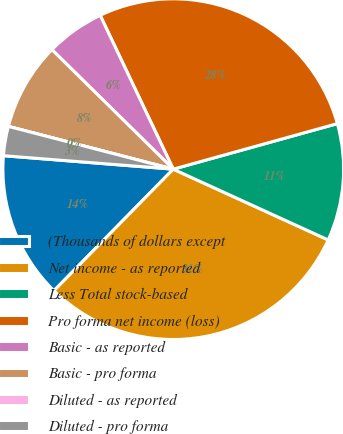Convert chart. <chart><loc_0><loc_0><loc_500><loc_500><pie_chart><fcel>(Thousands of dollars except<fcel>Net income - as reported<fcel>Less Total stock-based<fcel>Pro forma net income (loss)<fcel>Basic - as reported<fcel>Basic - pro forma<fcel>Diluted - as reported<fcel>Diluted - pro forma<nl><fcel>13.91%<fcel>30.53%<fcel>11.13%<fcel>27.75%<fcel>5.56%<fcel>8.34%<fcel>0.0%<fcel>2.78%<nl></chart> 